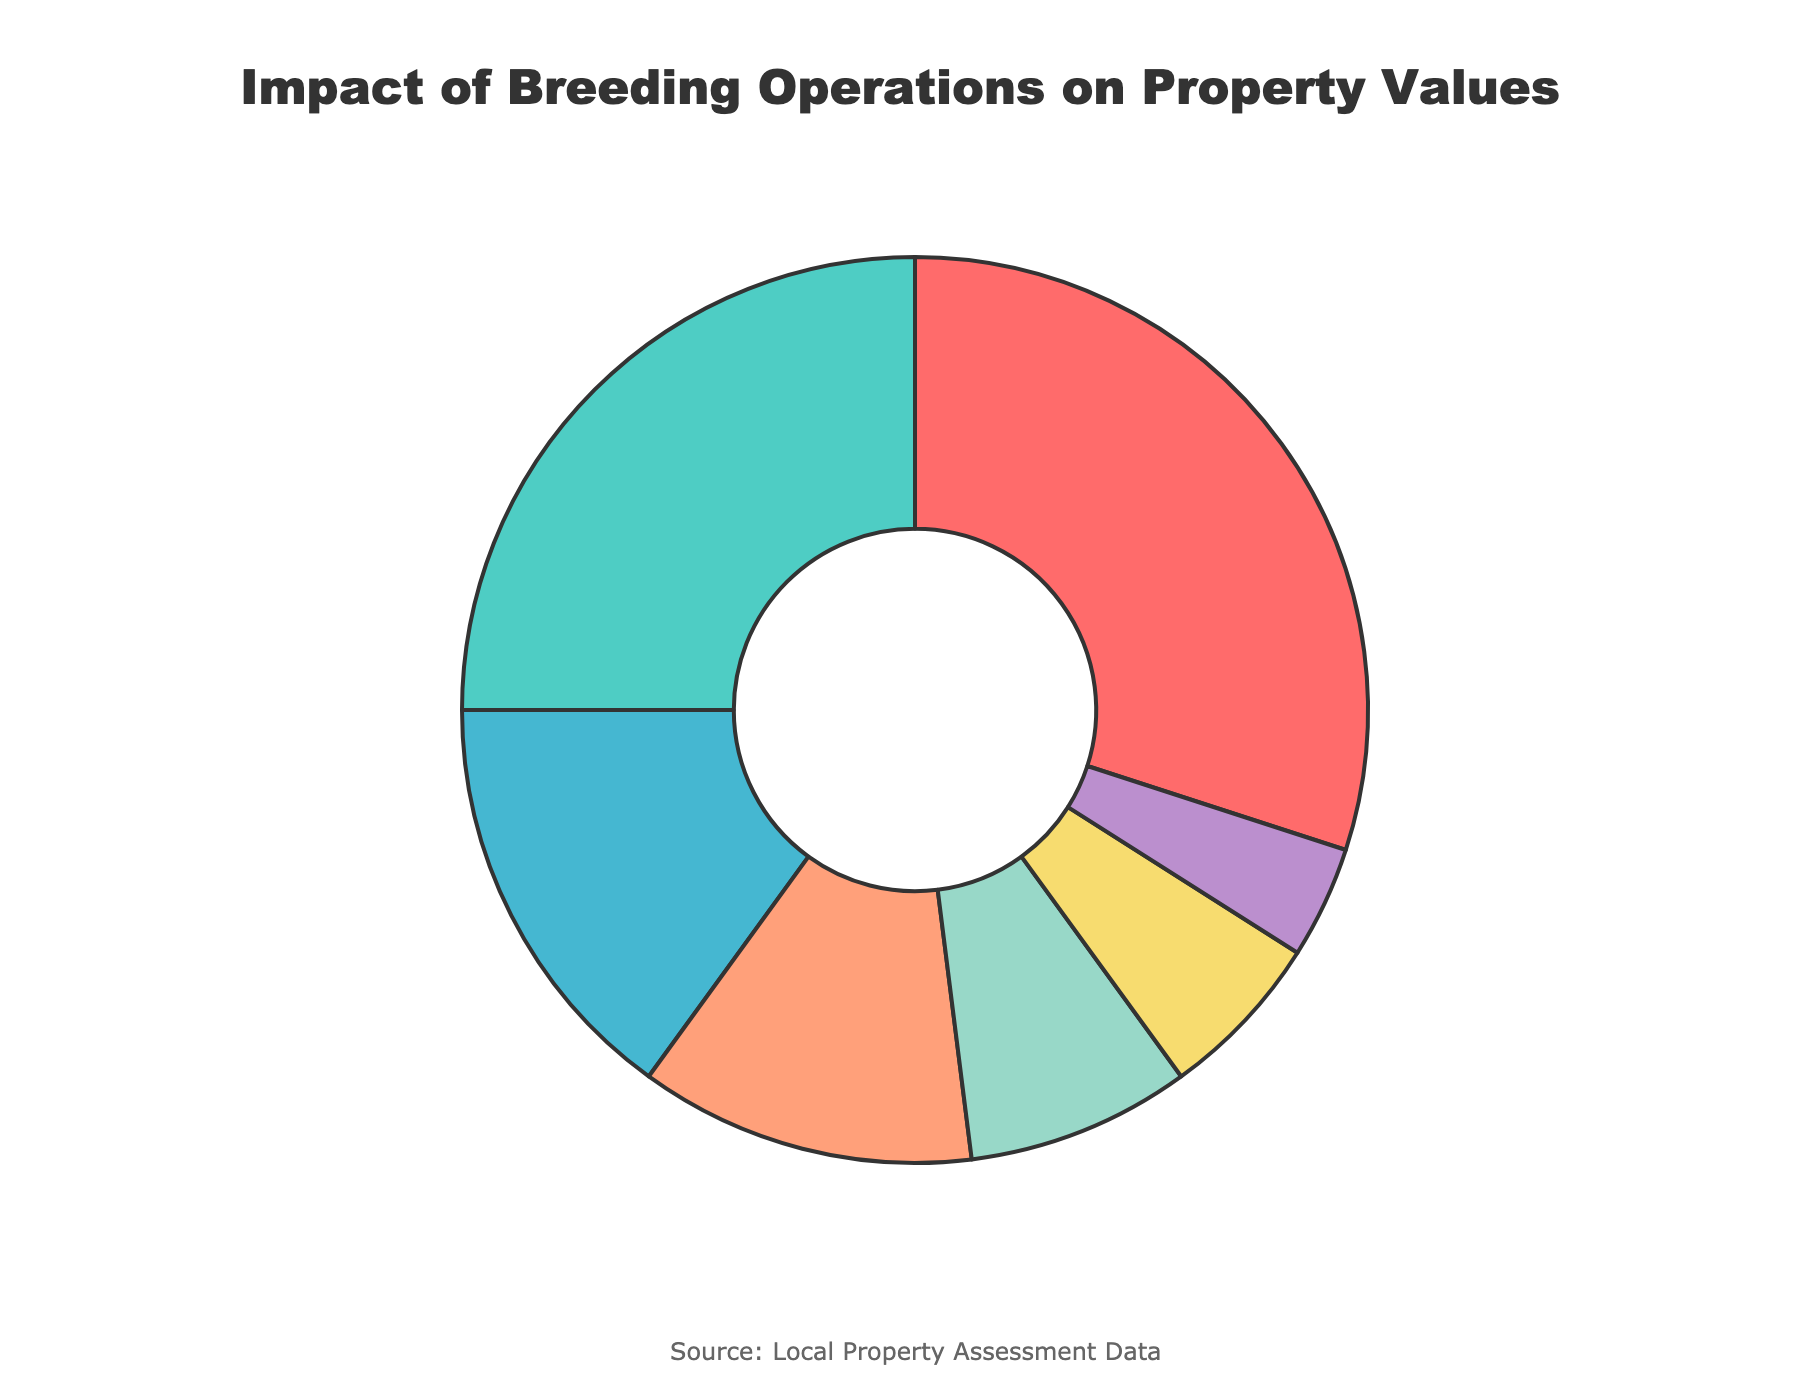what reason contributes the most to property value decrease? The largest segment of the pie chart represents Noise pollution from breeding facilities, accounting for 30% of the total.
Answer: Noise pollution from breeding facilities Which two reasons combined contribute equally to noise pollution? Odor and air quality issues contribute 25% and Increased traffic from transport vehicles contribute 15%. Combined, they contribute 25% + 15% = 40%, which is not equal to Noise pollution (30%). However, Visual impact on landscape (12%) and Water contamination concerns (8%) combined (12% + 8% = 20%) are less, so a simpler combination of one equal to noise does not exist. Noise pollution stands alone as the highest single contributor separately.
Answer: No exact pair Is the visual impact on landscape contribution greater than pest and rodent problems? The visual impact on the landscape contributes 12% while pest and rodent problems contribute 6%. 12% is greater than 6%.
Answer: Yes What is the sum of the contributions from water contamination concerns and decreased appeal to potential buyers? Water contamination concerns contribute 8% and decreased appeal to potential buyers contribute 4%. Their sum is 8% + 4%.
Answer: 12% Name an issue that contributes less to property value decrease than increased traffic. Increased traffic from transport vehicles contributes 15%. One issue that contributes less than 15% is visual impact on the landscape, which contributes 12%.
Answer: Visual impact on landscape What is the difference between the highest and lowest contributing reasons? The highest contributing reason is noise pollution from breeding facilities at 30%, and the lowest is decreased appeal to potential buyers at 4%. The difference is 30% - 4%.
Answer: 26% 